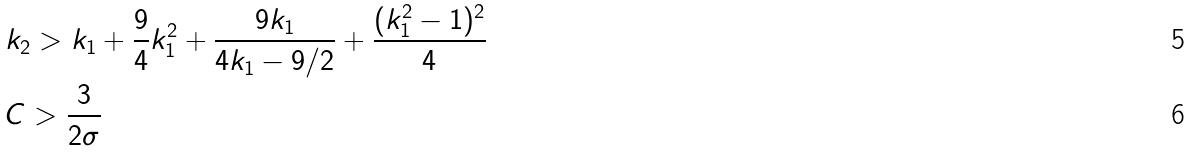Convert formula to latex. <formula><loc_0><loc_0><loc_500><loc_500>& k _ { 2 } > k _ { 1 } + \frac { 9 } { 4 } k _ { 1 } ^ { 2 } + \frac { 9 k _ { 1 } } { 4 k _ { 1 } - 9 / 2 } + \frac { ( k _ { 1 } ^ { 2 } - 1 ) ^ { 2 } } { 4 } \\ & C > \frac { 3 } { 2 \sigma }</formula> 